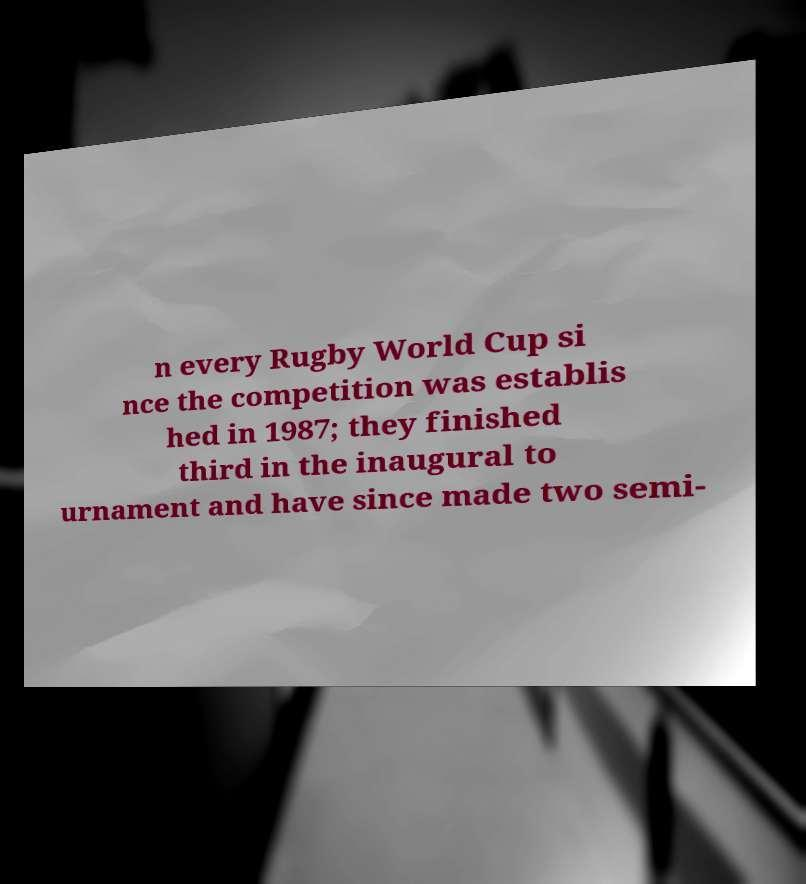Can you read and provide the text displayed in the image?This photo seems to have some interesting text. Can you extract and type it out for me? n every Rugby World Cup si nce the competition was establis hed in 1987; they finished third in the inaugural to urnament and have since made two semi- 